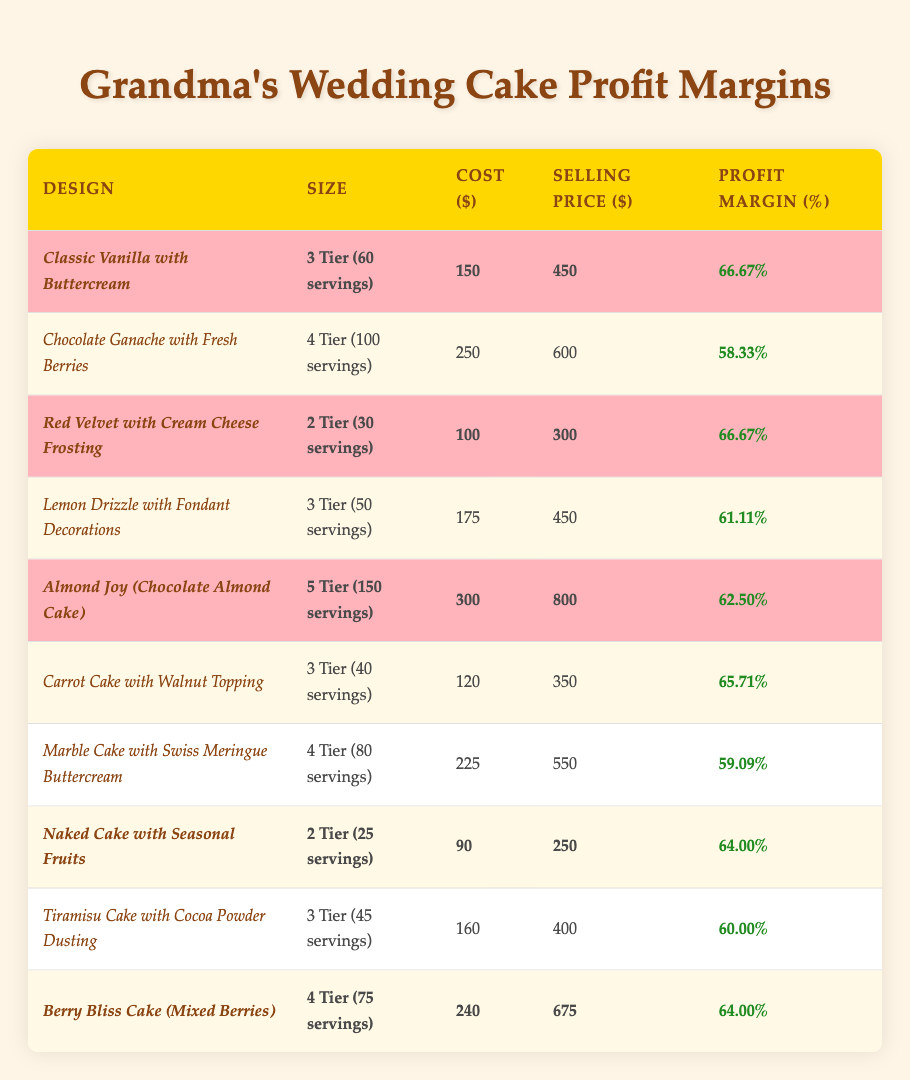What is the profit margin of the Classic Vanilla with Buttercream cake? The table lists the profit margin for the Classic Vanilla with Buttercream cake as 66.67%.
Answer: 66.67% How many servings does the Almond Joy cake provide? The Almond Joy cake is listed as a 5 Tier cake, which serves 150 guests according to the table.
Answer: 150 servings Which cake has the highest profit margin percentage? The Classic Vanilla with Buttercream and Red Velvet with Cream Cheese Frosting both have the highest profit margin percentage of 66.67%.
Answer: Classic Vanilla with Buttercream and Red Velvet with Cream Cheese Frosting What is the selling price of the Naked Cake with Seasonal Fruits? The selling price for the Naked Cake with Seasonal Fruits is listed as $250 in the table.
Answer: $250 If one wanted to calculate the average profit margin of the highlighted cakes, what would be the average percentage? The highlighted cakes are: Classic Vanilla (66.67%), Red Velvet (66.67%), Almond Joy (62.50%), Naked Cake (64.00%), and Berry Bliss (64.00%). The sum of their profit margins is 66.67 + 66.67 + 62.50 + 64.00 + 64.00 = 325.84, and there are 5 cakes, so the average is 325.84 / 5 = 65.17%.
Answer: 65.17% Is the profit margin for the Lemon Drizzle with Fondant Decorations greater than 60%? The profit margin for the Lemon Drizzle cake is 61.11%, which is indeed greater than 60%.
Answer: Yes What is the total cost of creating a Chocolate Ganache with Fresh Berries cake and a Marble Cake with Swiss Meringue Buttercream cake? The cost of Chocolate Ganache is $250 and Marble Cake is $225, adding them gives $250 + $225 = $475 as the total cost.
Answer: $475 How many cakes are highlighted in the table? The highlighted cakes in the table are: Classic Vanilla, Red Velvet, Almond Joy, Naked Cake, and Berry Bliss. Counting these gives a total of 5 highlighted cakes.
Answer: 5 highlighted cakes Which cake has the lowest selling price, and what is that price? The lowest selling price cake in the table is the Naked Cake with Seasonal Fruits, selling for $250.
Answer: $250 What is the profit margin difference between the Berry Bliss Cake and the Chocolate Ganache cake? The profit margin for Berry Bliss Cake is 64.00% and for Chocolate Ganache, it is 58.33%. The difference is 64.00 - 58.33 = 5.67%.
Answer: 5.67% 